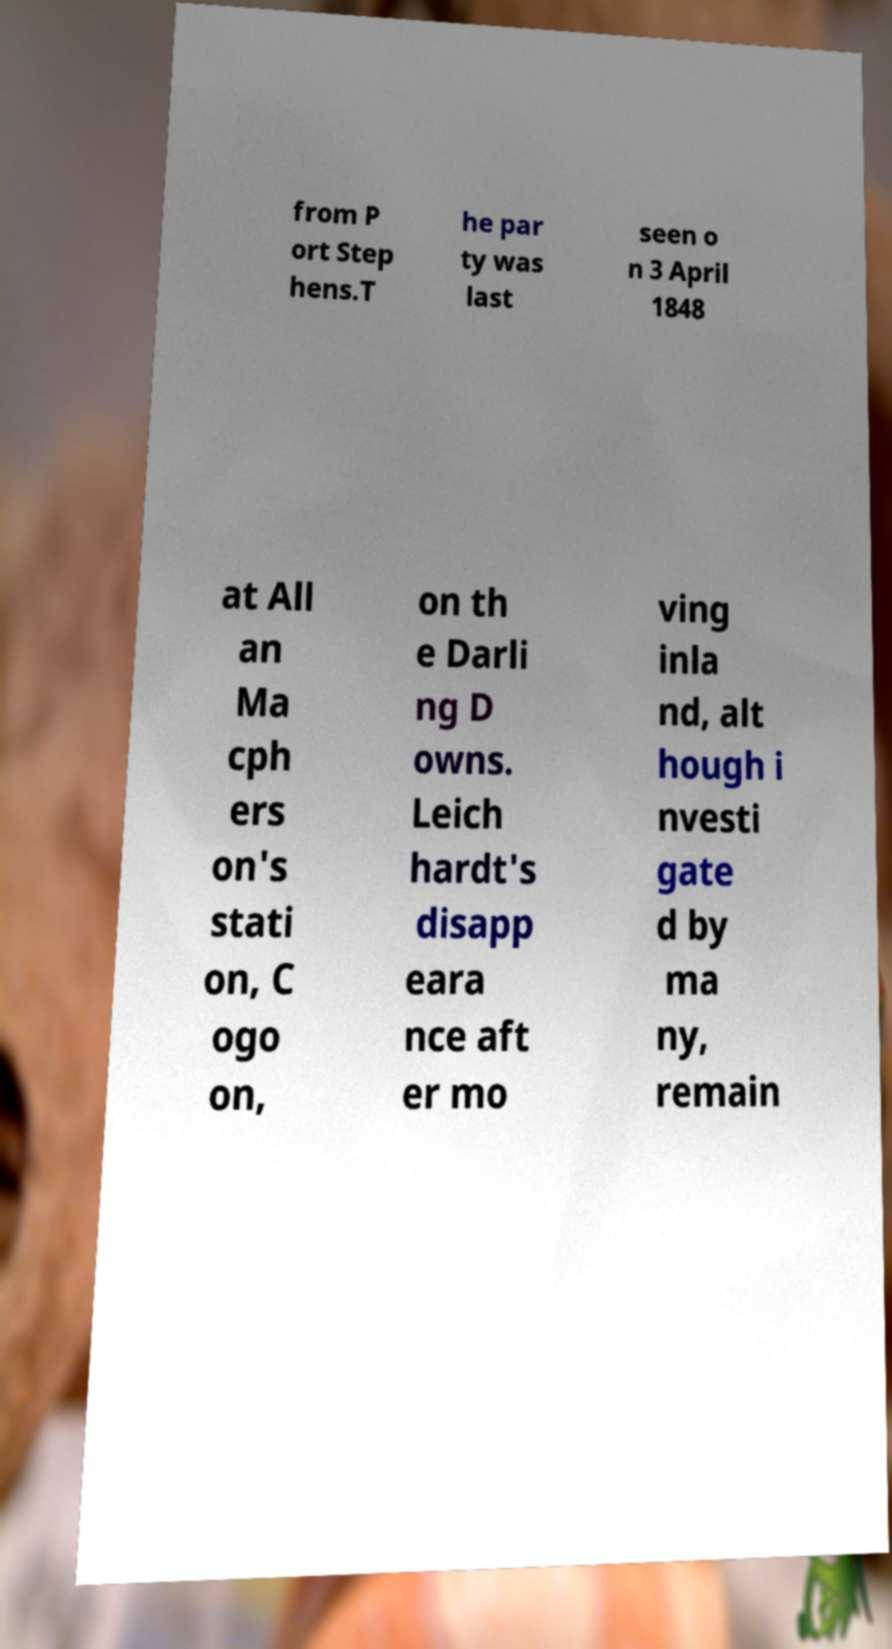For documentation purposes, I need the text within this image transcribed. Could you provide that? from P ort Step hens.T he par ty was last seen o n 3 April 1848 at All an Ma cph ers on's stati on, C ogo on, on th e Darli ng D owns. Leich hardt's disapp eara nce aft er mo ving inla nd, alt hough i nvesti gate d by ma ny, remain 